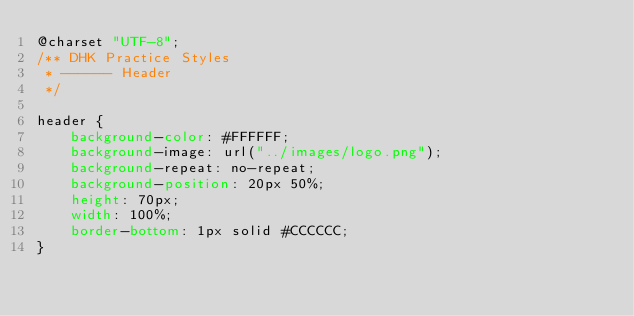Convert code to text. <code><loc_0><loc_0><loc_500><loc_500><_CSS_>@charset "UTF-8";
/** DHK Practice Styles
 * ------ Header
 */

header {
	background-color: #FFFFFF;
	background-image: url("../images/logo.png");
	background-repeat: no-repeat;
	background-position: 20px 50%;
	height: 70px;
	width: 100%;
	border-bottom: 1px solid #CCCCCC;
}
</code> 